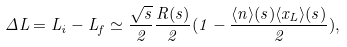<formula> <loc_0><loc_0><loc_500><loc_500>\Delta L = L _ { i } - L _ { f } \simeq \frac { \sqrt { s } } { 2 } \frac { R ( s ) } { 2 } ( 1 - \frac { \langle n \rangle ( s ) \langle x _ { L } \rangle ( s ) } { 2 } ) ,</formula> 